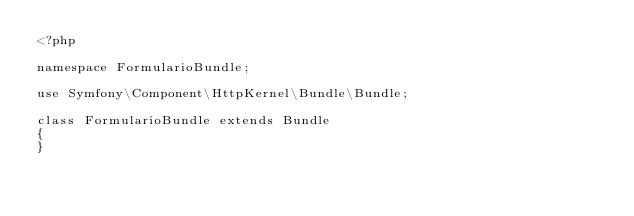Convert code to text. <code><loc_0><loc_0><loc_500><loc_500><_PHP_><?php

namespace FormularioBundle;

use Symfony\Component\HttpKernel\Bundle\Bundle;

class FormularioBundle extends Bundle
{
}
</code> 